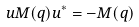<formula> <loc_0><loc_0><loc_500><loc_500>u M ( q ) u ^ { * } = - M ( q )</formula> 